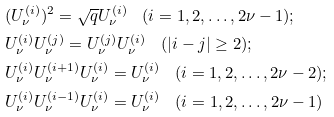Convert formula to latex. <formula><loc_0><loc_0><loc_500><loc_500>& ( U _ { \nu } ^ { ( i ) } ) ^ { 2 } = \sqrt { q } U _ { \nu } ^ { ( i ) } \quad ( i = 1 , 2 , \dots , 2 \nu - 1 ) ; \\ & U _ { \nu } ^ { ( i ) } U _ { \nu } ^ { ( j ) } = U _ { \nu } ^ { ( j ) } U _ { \nu } ^ { ( i ) } \quad ( | i - j | \geq 2 ) ; \\ & U _ { \nu } ^ { ( i ) } U _ { \nu } ^ { ( i + 1 ) } U _ { \nu } ^ { ( i ) } = U _ { \nu } ^ { ( i ) } \quad ( i = 1 , 2 , \dots , 2 \nu - 2 ) ; \\ & U _ { \nu } ^ { ( i ) } U _ { \nu } ^ { ( i - 1 ) } U _ { \nu } ^ { ( i ) } = U _ { \nu } ^ { ( i ) } \quad ( i = 1 , 2 , \dots , 2 \nu - 1 )</formula> 